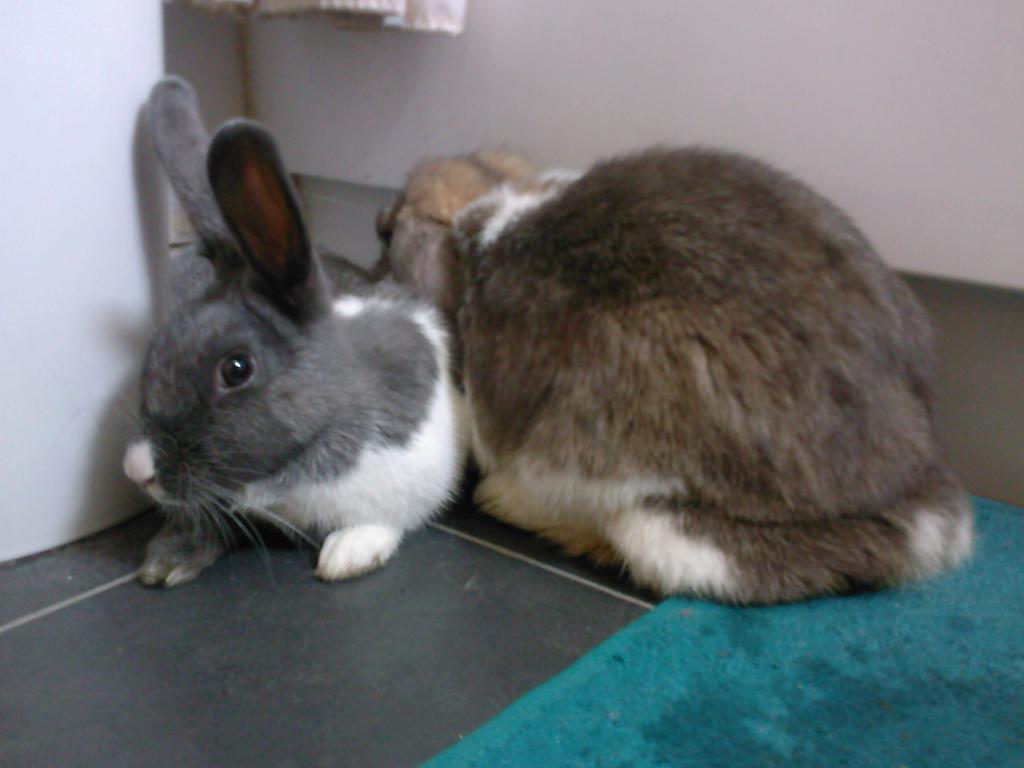Could you give a brief overview of what you see in this image? Here in this picture we can see a couple of rabbits present on the floor over there and on the right side we can see floor mat present over there. 